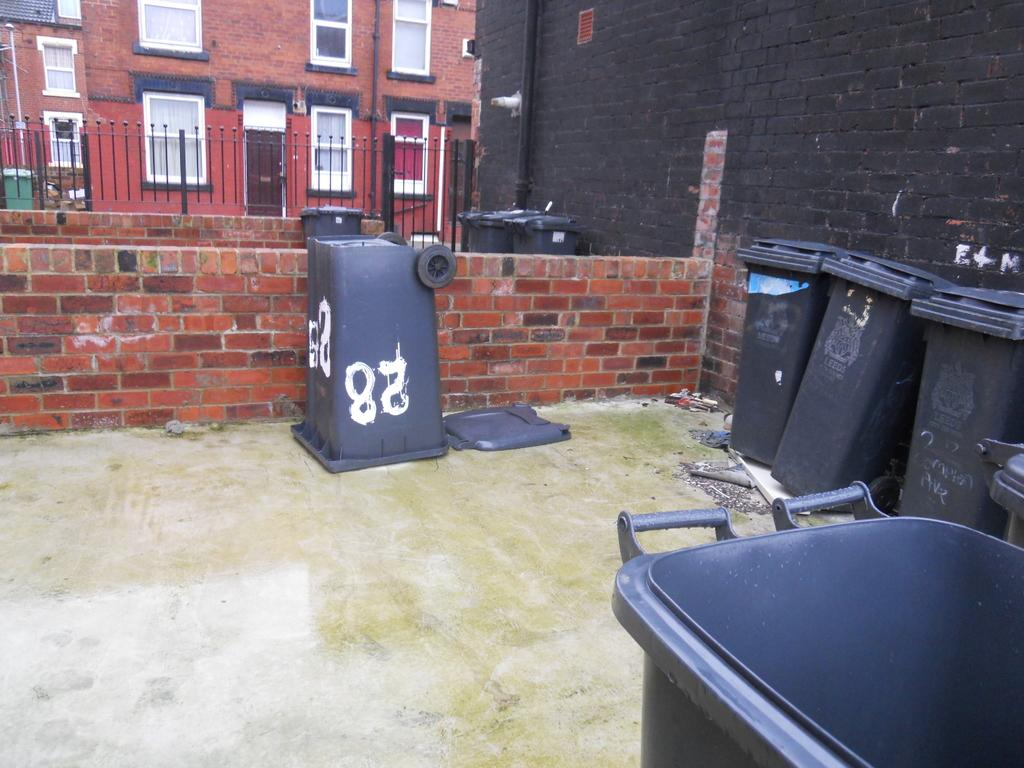<image>
Write a terse but informative summary of the picture. Black garbage can with the numbers 28 in white. 